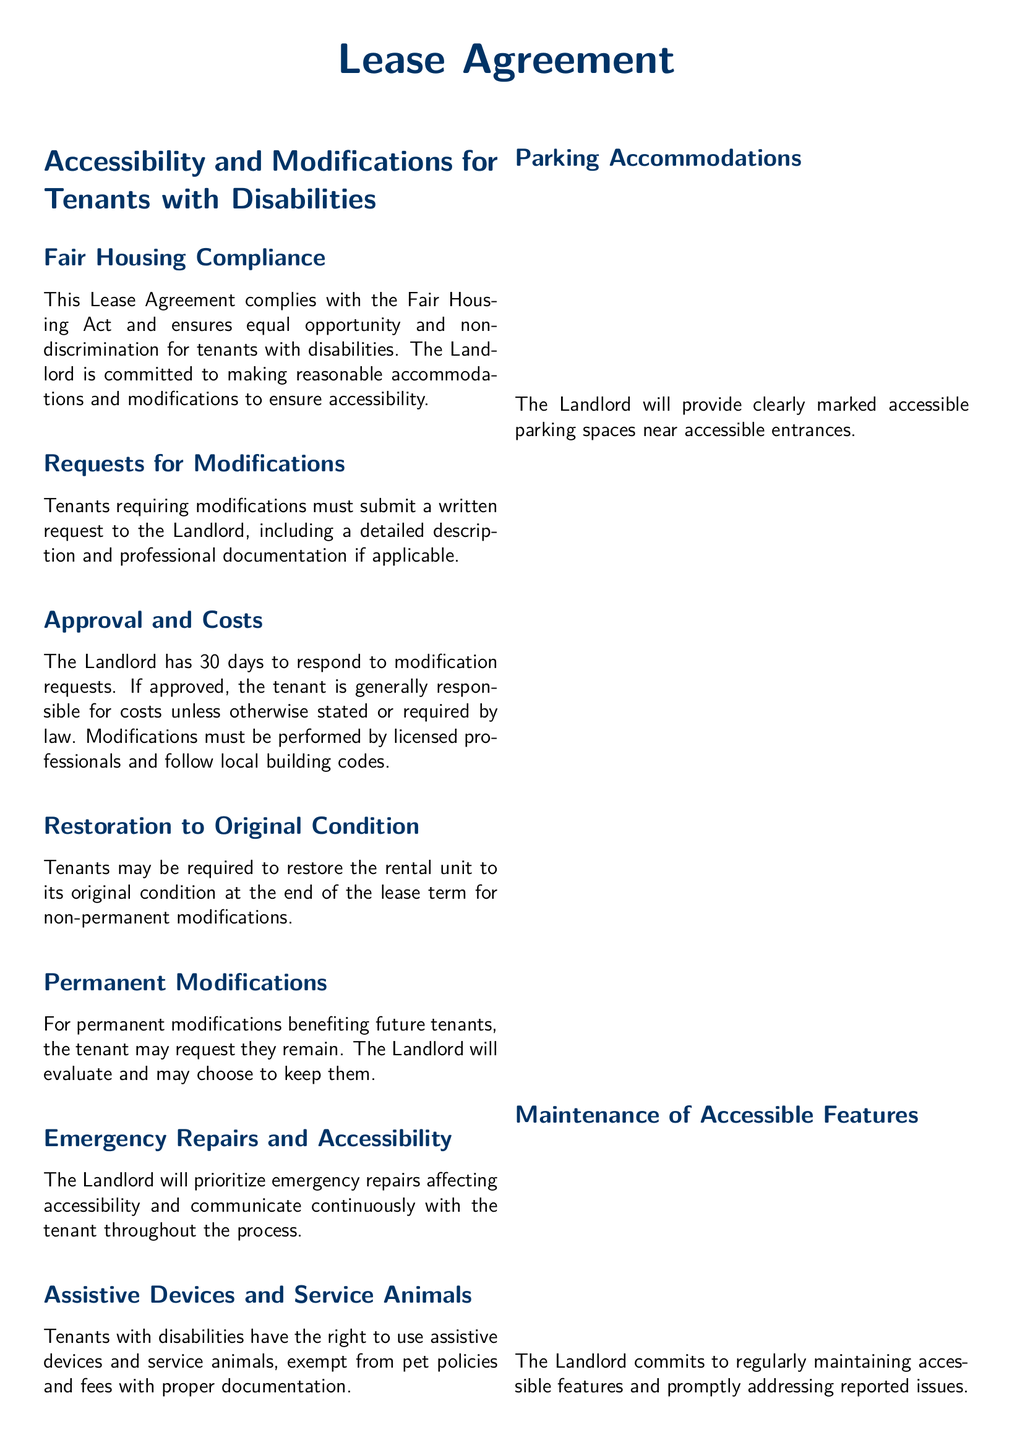What does this Lease Agreement comply with? The Lease Agreement ensures compliance with the Fair Housing Act to promote equality and non-discrimination for tenants with disabilities.
Answer: Fair Housing Act How many days does the Landlord have to respond to modification requests? The document states that the Landlord has a specific timeframe to respond to tenant requests for modifications, which is 30 days.
Answer: 30 days Who is generally responsible for costs of approved modifications? The responsibility of costs associated with approved modifications is typically designated in the Lease Agreement. The tenant is generally responsible unless stated otherwise.
Answer: Tenant What must be included in a request for modifications? A proper request for modifications must include specific components as outlined in the Lease Agreement to ensure necessary details are provided.
Answer: Detailed description and professional documentation What is the tenant allowed to use without being subjected to pet policies? The agreement specifies that there are allowances for tenants with disabilities regarding certain supportive items that typically are restricted under regular pet policies.
Answer: Assistive devices and service animals What must tenants do with non-permanent modifications at the lease end? The Lease Agreement outlines a requirement regarding the condition of the rental unit upon the conclusion of the lease term related to non-permanent modifications.
Answer: Restore to original condition What is assured in terms of emergency repairs that affect accessibility? The document emphasizes a commitment regarding how emergency repairs that impact accessibility will be prioritized, ensuring effective communication.
Answer: Prioritized and communicated How are accessible parking spaces described in the Lease Agreement? The Lease describes the provision of parking accommodations and their description, focusing on signage and proximity to entrances to maintain accessibility.
Answer: Clearly marked accessible parking spaces What will the Landlord evaluate if a tenant requests to keep permanent modifications? The Lease Agreement outlines the process regarding how the Landlord will approach requests related to permanent modifications that benefit future tenants.
Answer: Evaluate and may choose to keep them 